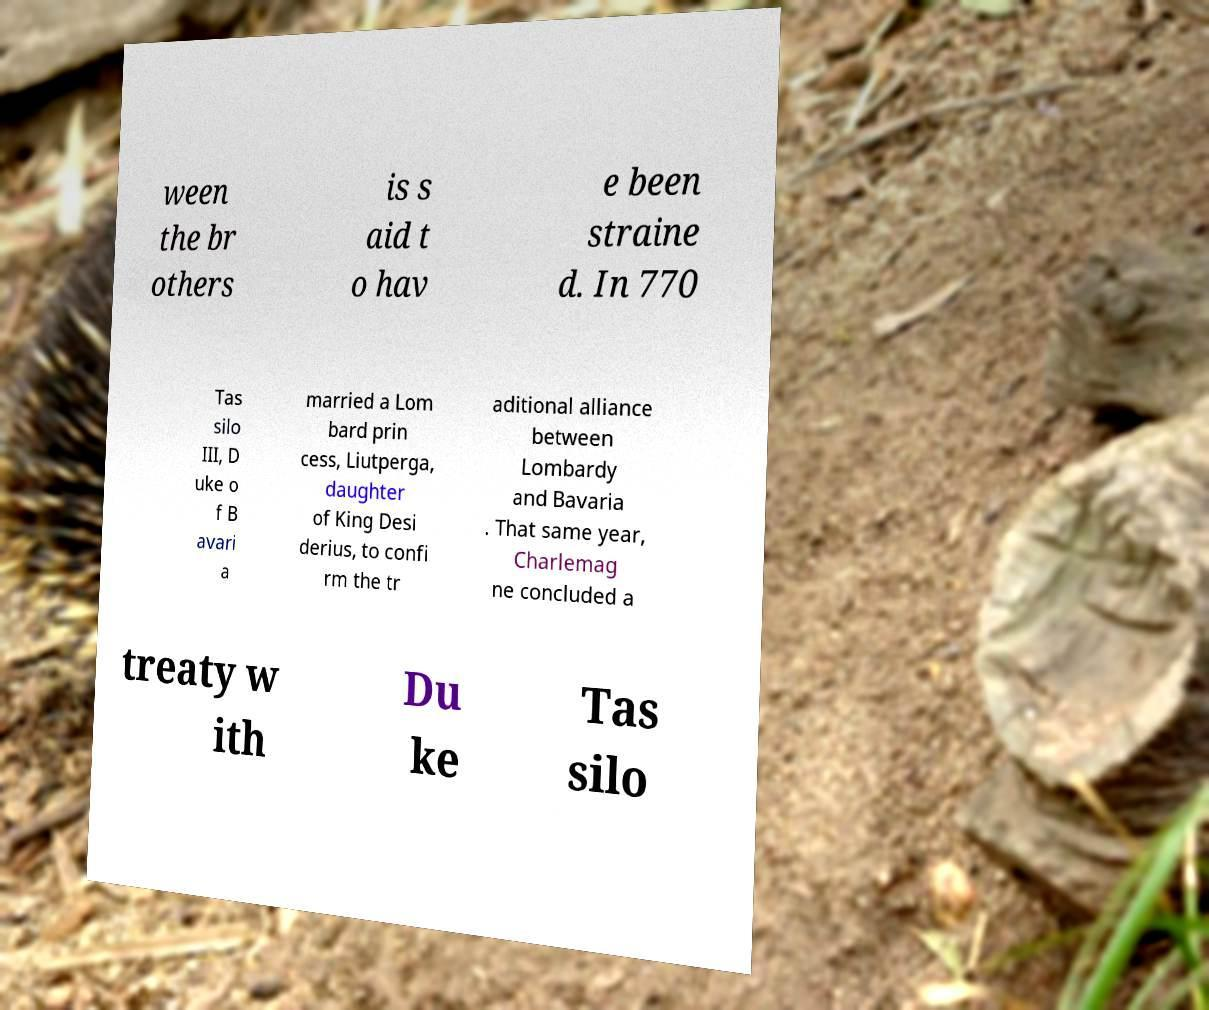For documentation purposes, I need the text within this image transcribed. Could you provide that? ween the br others is s aid t o hav e been straine d. In 770 Tas silo III, D uke o f B avari a married a Lom bard prin cess, Liutperga, daughter of King Desi derius, to confi rm the tr aditional alliance between Lombardy and Bavaria . That same year, Charlemag ne concluded a treaty w ith Du ke Tas silo 